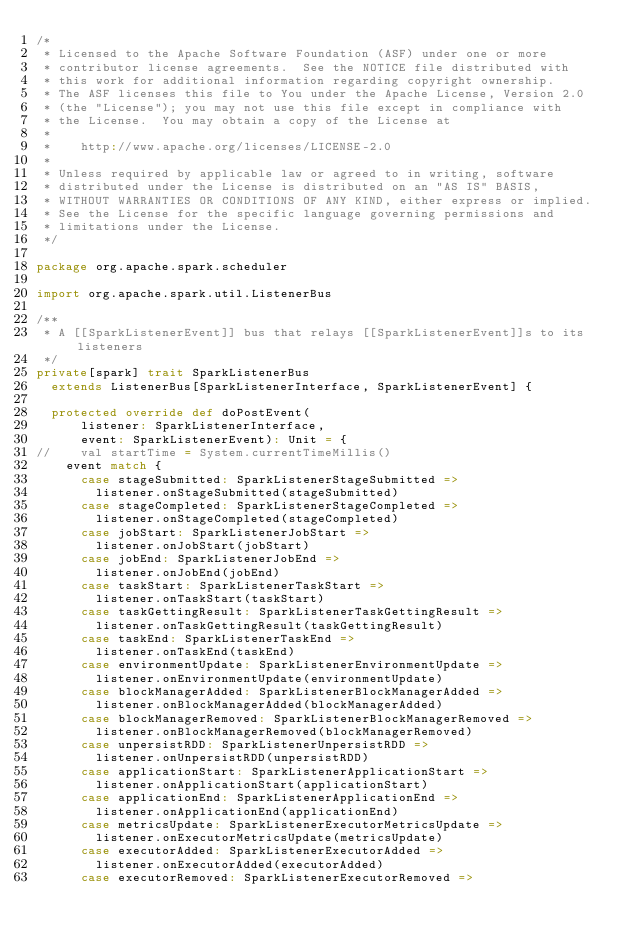<code> <loc_0><loc_0><loc_500><loc_500><_Scala_>/*
 * Licensed to the Apache Software Foundation (ASF) under one or more
 * contributor license agreements.  See the NOTICE file distributed with
 * this work for additional information regarding copyright ownership.
 * The ASF licenses this file to You under the Apache License, Version 2.0
 * (the "License"); you may not use this file except in compliance with
 * the License.  You may obtain a copy of the License at
 *
 *    http://www.apache.org/licenses/LICENSE-2.0
 *
 * Unless required by applicable law or agreed to in writing, software
 * distributed under the License is distributed on an "AS IS" BASIS,
 * WITHOUT WARRANTIES OR CONDITIONS OF ANY KIND, either express or implied.
 * See the License for the specific language governing permissions and
 * limitations under the License.
 */

package org.apache.spark.scheduler

import org.apache.spark.util.ListenerBus

/**
 * A [[SparkListenerEvent]] bus that relays [[SparkListenerEvent]]s to its listeners
 */
private[spark] trait SparkListenerBus
  extends ListenerBus[SparkListenerInterface, SparkListenerEvent] {

  protected override def doPostEvent(
      listener: SparkListenerInterface,
      event: SparkListenerEvent): Unit = {
//    val startTime = System.currentTimeMillis()
    event match {
      case stageSubmitted: SparkListenerStageSubmitted =>
        listener.onStageSubmitted(stageSubmitted)
      case stageCompleted: SparkListenerStageCompleted =>
        listener.onStageCompleted(stageCompleted)
      case jobStart: SparkListenerJobStart =>
        listener.onJobStart(jobStart)
      case jobEnd: SparkListenerJobEnd =>
        listener.onJobEnd(jobEnd)
      case taskStart: SparkListenerTaskStart =>
        listener.onTaskStart(taskStart)
      case taskGettingResult: SparkListenerTaskGettingResult =>
        listener.onTaskGettingResult(taskGettingResult)
      case taskEnd: SparkListenerTaskEnd =>
        listener.onTaskEnd(taskEnd)
      case environmentUpdate: SparkListenerEnvironmentUpdate =>
        listener.onEnvironmentUpdate(environmentUpdate)
      case blockManagerAdded: SparkListenerBlockManagerAdded =>
        listener.onBlockManagerAdded(blockManagerAdded)
      case blockManagerRemoved: SparkListenerBlockManagerRemoved =>
        listener.onBlockManagerRemoved(blockManagerRemoved)
      case unpersistRDD: SparkListenerUnpersistRDD =>
        listener.onUnpersistRDD(unpersistRDD)
      case applicationStart: SparkListenerApplicationStart =>
        listener.onApplicationStart(applicationStart)
      case applicationEnd: SparkListenerApplicationEnd =>
        listener.onApplicationEnd(applicationEnd)
      case metricsUpdate: SparkListenerExecutorMetricsUpdate =>
        listener.onExecutorMetricsUpdate(metricsUpdate)
      case executorAdded: SparkListenerExecutorAdded =>
        listener.onExecutorAdded(executorAdded)
      case executorRemoved: SparkListenerExecutorRemoved =></code> 